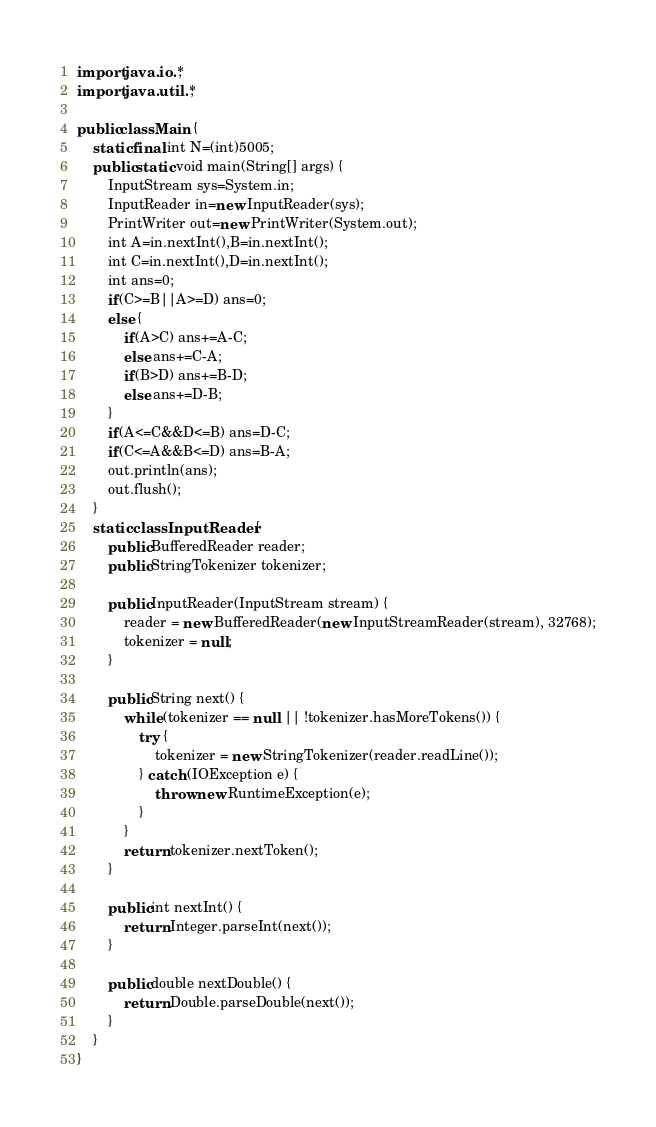<code> <loc_0><loc_0><loc_500><loc_500><_Java_>

import java.io.*;
import java.util.*;

public class Main {
	static final int N=(int)5005;
    public static void main(String[] args) {  
        InputStream sys=System.in;
        InputReader in=new InputReader(sys);
        PrintWriter out=new PrintWriter(System.out);
        int A=in.nextInt(),B=in.nextInt();
        int C=in.nextInt(),D=in.nextInt();
        int ans=0;
        if(C>=B||A>=D) ans=0;
        else {
        	if(A>C) ans+=A-C;
        	else ans+=C-A;
        	if(B>D) ans+=B-D;
        	else ans+=D-B;
        }
        if(A<=C&&D<=B) ans=D-C;
        if(C<=A&&B<=D) ans=B-A;
        out.println(ans);
        out.flush();
    }
	static class InputReader {
		public BufferedReader reader;
		public StringTokenizer tokenizer;
        
		public InputReader(InputStream stream) {
			reader = new BufferedReader(new InputStreamReader(stream), 32768);
			tokenizer = null;
		}

		public String next() {
			while (tokenizer == null || !tokenizer.hasMoreTokens()) {
				try {
					tokenizer = new StringTokenizer(reader.readLine());
				} catch (IOException e) {
					throw new RuntimeException(e);
				}
			}
			return tokenizer.nextToken();
		}

		public int nextInt() {
			return Integer.parseInt(next());
		}
		
		public double nextDouble() {
			return Double.parseDouble(next());
		}
	}
}</code> 